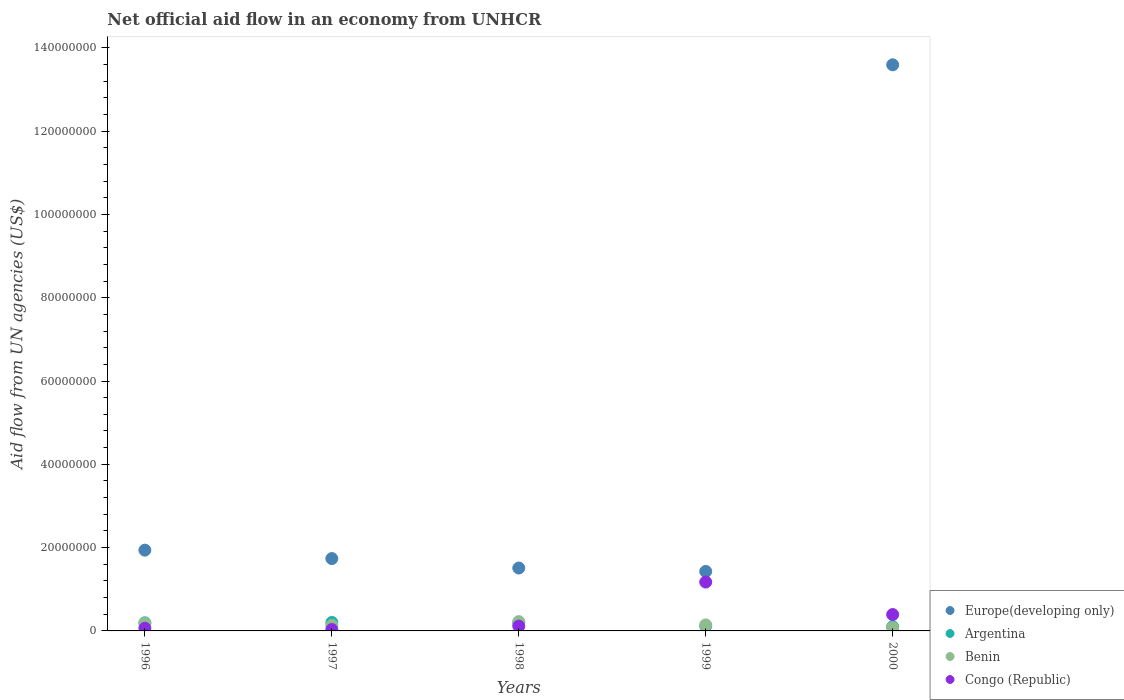Is the number of dotlines equal to the number of legend labels?
Your answer should be compact. Yes. What is the net official aid flow in Argentina in 1999?
Provide a succinct answer. 1.16e+06. Across all years, what is the maximum net official aid flow in Europe(developing only)?
Your answer should be compact. 1.36e+08. Across all years, what is the minimum net official aid flow in Congo (Republic)?
Keep it short and to the point. 3.30e+05. What is the total net official aid flow in Congo (Republic) in the graph?
Provide a succinct answer. 1.78e+07. What is the difference between the net official aid flow in Benin in 1998 and that in 2000?
Make the answer very short. 1.46e+06. What is the difference between the net official aid flow in Benin in 1997 and the net official aid flow in Congo (Republic) in 2000?
Offer a terse response. -2.59e+06. What is the average net official aid flow in Benin per year?
Make the answer very short. 1.52e+06. In the year 1997, what is the difference between the net official aid flow in Congo (Republic) and net official aid flow in Europe(developing only)?
Provide a succinct answer. -1.70e+07. In how many years, is the net official aid flow in Benin greater than 12000000 US$?
Ensure brevity in your answer.  0. What is the ratio of the net official aid flow in Benin in 1998 to that in 2000?
Offer a very short reply. 2.9. Is the net official aid flow in Benin in 1997 less than that in 1999?
Provide a succinct answer. Yes. Is the difference between the net official aid flow in Congo (Republic) in 1997 and 1998 greater than the difference between the net official aid flow in Europe(developing only) in 1997 and 1998?
Your response must be concise. No. What is the difference between the highest and the second highest net official aid flow in Benin?
Give a very brief answer. 4.40e+05. What is the difference between the highest and the lowest net official aid flow in Congo (Republic)?
Offer a very short reply. 1.14e+07. In how many years, is the net official aid flow in Congo (Republic) greater than the average net official aid flow in Congo (Republic) taken over all years?
Give a very brief answer. 2. Is it the case that in every year, the sum of the net official aid flow in Congo (Republic) and net official aid flow in Europe(developing only)  is greater than the sum of net official aid flow in Benin and net official aid flow in Argentina?
Keep it short and to the point. No. Is the net official aid flow in Benin strictly greater than the net official aid flow in Congo (Republic) over the years?
Keep it short and to the point. No. How many years are there in the graph?
Provide a succinct answer. 5. What is the difference between two consecutive major ticks on the Y-axis?
Keep it short and to the point. 2.00e+07. Does the graph contain grids?
Give a very brief answer. No. Where does the legend appear in the graph?
Provide a succinct answer. Bottom right. What is the title of the graph?
Provide a succinct answer. Net official aid flow in an economy from UNHCR. What is the label or title of the Y-axis?
Provide a succinct answer. Aid flow from UN agencies (US$). What is the Aid flow from UN agencies (US$) in Europe(developing only) in 1996?
Your answer should be compact. 1.94e+07. What is the Aid flow from UN agencies (US$) in Argentina in 1996?
Offer a very short reply. 1.95e+06. What is the Aid flow from UN agencies (US$) in Benin in 1996?
Ensure brevity in your answer.  1.79e+06. What is the Aid flow from UN agencies (US$) in Congo (Republic) in 1996?
Keep it short and to the point. 6.50e+05. What is the Aid flow from UN agencies (US$) in Europe(developing only) in 1997?
Make the answer very short. 1.74e+07. What is the Aid flow from UN agencies (US$) of Argentina in 1997?
Offer a terse response. 2.04e+06. What is the Aid flow from UN agencies (US$) of Benin in 1997?
Give a very brief answer. 1.34e+06. What is the Aid flow from UN agencies (US$) of Europe(developing only) in 1998?
Your answer should be very brief. 1.51e+07. What is the Aid flow from UN agencies (US$) in Argentina in 1998?
Your answer should be compact. 1.97e+06. What is the Aid flow from UN agencies (US$) in Benin in 1998?
Ensure brevity in your answer.  2.23e+06. What is the Aid flow from UN agencies (US$) of Congo (Republic) in 1998?
Make the answer very short. 1.15e+06. What is the Aid flow from UN agencies (US$) of Europe(developing only) in 1999?
Offer a terse response. 1.43e+07. What is the Aid flow from UN agencies (US$) in Argentina in 1999?
Give a very brief answer. 1.16e+06. What is the Aid flow from UN agencies (US$) of Benin in 1999?
Your answer should be very brief. 1.45e+06. What is the Aid flow from UN agencies (US$) in Congo (Republic) in 1999?
Give a very brief answer. 1.17e+07. What is the Aid flow from UN agencies (US$) in Europe(developing only) in 2000?
Offer a terse response. 1.36e+08. What is the Aid flow from UN agencies (US$) in Argentina in 2000?
Keep it short and to the point. 1.02e+06. What is the Aid flow from UN agencies (US$) in Benin in 2000?
Provide a short and direct response. 7.70e+05. What is the Aid flow from UN agencies (US$) in Congo (Republic) in 2000?
Provide a short and direct response. 3.93e+06. Across all years, what is the maximum Aid flow from UN agencies (US$) in Europe(developing only)?
Keep it short and to the point. 1.36e+08. Across all years, what is the maximum Aid flow from UN agencies (US$) in Argentina?
Offer a terse response. 2.04e+06. Across all years, what is the maximum Aid flow from UN agencies (US$) of Benin?
Your response must be concise. 2.23e+06. Across all years, what is the maximum Aid flow from UN agencies (US$) of Congo (Republic)?
Your answer should be very brief. 1.17e+07. Across all years, what is the minimum Aid flow from UN agencies (US$) of Europe(developing only)?
Provide a succinct answer. 1.43e+07. Across all years, what is the minimum Aid flow from UN agencies (US$) of Argentina?
Make the answer very short. 1.02e+06. Across all years, what is the minimum Aid flow from UN agencies (US$) of Benin?
Your answer should be compact. 7.70e+05. Across all years, what is the minimum Aid flow from UN agencies (US$) of Congo (Republic)?
Your response must be concise. 3.30e+05. What is the total Aid flow from UN agencies (US$) in Europe(developing only) in the graph?
Provide a short and direct response. 2.02e+08. What is the total Aid flow from UN agencies (US$) of Argentina in the graph?
Your answer should be compact. 8.14e+06. What is the total Aid flow from UN agencies (US$) of Benin in the graph?
Your answer should be very brief. 7.58e+06. What is the total Aid flow from UN agencies (US$) of Congo (Republic) in the graph?
Your answer should be very brief. 1.78e+07. What is the difference between the Aid flow from UN agencies (US$) of Europe(developing only) in 1996 and that in 1997?
Provide a succinct answer. 2.02e+06. What is the difference between the Aid flow from UN agencies (US$) in Europe(developing only) in 1996 and that in 1998?
Offer a terse response. 4.29e+06. What is the difference between the Aid flow from UN agencies (US$) in Argentina in 1996 and that in 1998?
Ensure brevity in your answer.  -2.00e+04. What is the difference between the Aid flow from UN agencies (US$) in Benin in 1996 and that in 1998?
Offer a terse response. -4.40e+05. What is the difference between the Aid flow from UN agencies (US$) of Congo (Republic) in 1996 and that in 1998?
Offer a very short reply. -5.00e+05. What is the difference between the Aid flow from UN agencies (US$) in Europe(developing only) in 1996 and that in 1999?
Provide a short and direct response. 5.11e+06. What is the difference between the Aid flow from UN agencies (US$) in Argentina in 1996 and that in 1999?
Ensure brevity in your answer.  7.90e+05. What is the difference between the Aid flow from UN agencies (US$) of Benin in 1996 and that in 1999?
Offer a terse response. 3.40e+05. What is the difference between the Aid flow from UN agencies (US$) in Congo (Republic) in 1996 and that in 1999?
Give a very brief answer. -1.11e+07. What is the difference between the Aid flow from UN agencies (US$) in Europe(developing only) in 1996 and that in 2000?
Offer a very short reply. -1.17e+08. What is the difference between the Aid flow from UN agencies (US$) in Argentina in 1996 and that in 2000?
Offer a very short reply. 9.30e+05. What is the difference between the Aid flow from UN agencies (US$) of Benin in 1996 and that in 2000?
Give a very brief answer. 1.02e+06. What is the difference between the Aid flow from UN agencies (US$) in Congo (Republic) in 1996 and that in 2000?
Provide a succinct answer. -3.28e+06. What is the difference between the Aid flow from UN agencies (US$) of Europe(developing only) in 1997 and that in 1998?
Offer a very short reply. 2.27e+06. What is the difference between the Aid flow from UN agencies (US$) in Benin in 1997 and that in 1998?
Offer a terse response. -8.90e+05. What is the difference between the Aid flow from UN agencies (US$) in Congo (Republic) in 1997 and that in 1998?
Give a very brief answer. -8.20e+05. What is the difference between the Aid flow from UN agencies (US$) in Europe(developing only) in 1997 and that in 1999?
Make the answer very short. 3.09e+06. What is the difference between the Aid flow from UN agencies (US$) in Argentina in 1997 and that in 1999?
Your answer should be very brief. 8.80e+05. What is the difference between the Aid flow from UN agencies (US$) in Benin in 1997 and that in 1999?
Your response must be concise. -1.10e+05. What is the difference between the Aid flow from UN agencies (US$) of Congo (Republic) in 1997 and that in 1999?
Your answer should be compact. -1.14e+07. What is the difference between the Aid flow from UN agencies (US$) of Europe(developing only) in 1997 and that in 2000?
Your answer should be compact. -1.19e+08. What is the difference between the Aid flow from UN agencies (US$) of Argentina in 1997 and that in 2000?
Give a very brief answer. 1.02e+06. What is the difference between the Aid flow from UN agencies (US$) in Benin in 1997 and that in 2000?
Give a very brief answer. 5.70e+05. What is the difference between the Aid flow from UN agencies (US$) of Congo (Republic) in 1997 and that in 2000?
Offer a terse response. -3.60e+06. What is the difference between the Aid flow from UN agencies (US$) of Europe(developing only) in 1998 and that in 1999?
Offer a terse response. 8.20e+05. What is the difference between the Aid flow from UN agencies (US$) in Argentina in 1998 and that in 1999?
Offer a very short reply. 8.10e+05. What is the difference between the Aid flow from UN agencies (US$) of Benin in 1998 and that in 1999?
Ensure brevity in your answer.  7.80e+05. What is the difference between the Aid flow from UN agencies (US$) in Congo (Republic) in 1998 and that in 1999?
Your answer should be compact. -1.06e+07. What is the difference between the Aid flow from UN agencies (US$) in Europe(developing only) in 1998 and that in 2000?
Provide a short and direct response. -1.21e+08. What is the difference between the Aid flow from UN agencies (US$) of Argentina in 1998 and that in 2000?
Your response must be concise. 9.50e+05. What is the difference between the Aid flow from UN agencies (US$) in Benin in 1998 and that in 2000?
Your response must be concise. 1.46e+06. What is the difference between the Aid flow from UN agencies (US$) in Congo (Republic) in 1998 and that in 2000?
Offer a very short reply. -2.78e+06. What is the difference between the Aid flow from UN agencies (US$) of Europe(developing only) in 1999 and that in 2000?
Your answer should be compact. -1.22e+08. What is the difference between the Aid flow from UN agencies (US$) in Benin in 1999 and that in 2000?
Give a very brief answer. 6.80e+05. What is the difference between the Aid flow from UN agencies (US$) in Congo (Republic) in 1999 and that in 2000?
Offer a terse response. 7.80e+06. What is the difference between the Aid flow from UN agencies (US$) of Europe(developing only) in 1996 and the Aid flow from UN agencies (US$) of Argentina in 1997?
Ensure brevity in your answer.  1.74e+07. What is the difference between the Aid flow from UN agencies (US$) of Europe(developing only) in 1996 and the Aid flow from UN agencies (US$) of Benin in 1997?
Offer a terse response. 1.80e+07. What is the difference between the Aid flow from UN agencies (US$) in Europe(developing only) in 1996 and the Aid flow from UN agencies (US$) in Congo (Republic) in 1997?
Ensure brevity in your answer.  1.91e+07. What is the difference between the Aid flow from UN agencies (US$) in Argentina in 1996 and the Aid flow from UN agencies (US$) in Congo (Republic) in 1997?
Make the answer very short. 1.62e+06. What is the difference between the Aid flow from UN agencies (US$) in Benin in 1996 and the Aid flow from UN agencies (US$) in Congo (Republic) in 1997?
Your answer should be very brief. 1.46e+06. What is the difference between the Aid flow from UN agencies (US$) in Europe(developing only) in 1996 and the Aid flow from UN agencies (US$) in Argentina in 1998?
Ensure brevity in your answer.  1.74e+07. What is the difference between the Aid flow from UN agencies (US$) in Europe(developing only) in 1996 and the Aid flow from UN agencies (US$) in Benin in 1998?
Provide a short and direct response. 1.72e+07. What is the difference between the Aid flow from UN agencies (US$) of Europe(developing only) in 1996 and the Aid flow from UN agencies (US$) of Congo (Republic) in 1998?
Make the answer very short. 1.82e+07. What is the difference between the Aid flow from UN agencies (US$) of Argentina in 1996 and the Aid flow from UN agencies (US$) of Benin in 1998?
Your answer should be very brief. -2.80e+05. What is the difference between the Aid flow from UN agencies (US$) in Argentina in 1996 and the Aid flow from UN agencies (US$) in Congo (Republic) in 1998?
Give a very brief answer. 8.00e+05. What is the difference between the Aid flow from UN agencies (US$) of Benin in 1996 and the Aid flow from UN agencies (US$) of Congo (Republic) in 1998?
Your response must be concise. 6.40e+05. What is the difference between the Aid flow from UN agencies (US$) of Europe(developing only) in 1996 and the Aid flow from UN agencies (US$) of Argentina in 1999?
Offer a very short reply. 1.82e+07. What is the difference between the Aid flow from UN agencies (US$) in Europe(developing only) in 1996 and the Aid flow from UN agencies (US$) in Benin in 1999?
Your answer should be compact. 1.79e+07. What is the difference between the Aid flow from UN agencies (US$) in Europe(developing only) in 1996 and the Aid flow from UN agencies (US$) in Congo (Republic) in 1999?
Offer a very short reply. 7.66e+06. What is the difference between the Aid flow from UN agencies (US$) of Argentina in 1996 and the Aid flow from UN agencies (US$) of Congo (Republic) in 1999?
Your answer should be compact. -9.78e+06. What is the difference between the Aid flow from UN agencies (US$) in Benin in 1996 and the Aid flow from UN agencies (US$) in Congo (Republic) in 1999?
Your answer should be compact. -9.94e+06. What is the difference between the Aid flow from UN agencies (US$) in Europe(developing only) in 1996 and the Aid flow from UN agencies (US$) in Argentina in 2000?
Your response must be concise. 1.84e+07. What is the difference between the Aid flow from UN agencies (US$) of Europe(developing only) in 1996 and the Aid flow from UN agencies (US$) of Benin in 2000?
Keep it short and to the point. 1.86e+07. What is the difference between the Aid flow from UN agencies (US$) in Europe(developing only) in 1996 and the Aid flow from UN agencies (US$) in Congo (Republic) in 2000?
Your answer should be very brief. 1.55e+07. What is the difference between the Aid flow from UN agencies (US$) of Argentina in 1996 and the Aid flow from UN agencies (US$) of Benin in 2000?
Your response must be concise. 1.18e+06. What is the difference between the Aid flow from UN agencies (US$) of Argentina in 1996 and the Aid flow from UN agencies (US$) of Congo (Republic) in 2000?
Ensure brevity in your answer.  -1.98e+06. What is the difference between the Aid flow from UN agencies (US$) of Benin in 1996 and the Aid flow from UN agencies (US$) of Congo (Republic) in 2000?
Keep it short and to the point. -2.14e+06. What is the difference between the Aid flow from UN agencies (US$) of Europe(developing only) in 1997 and the Aid flow from UN agencies (US$) of Argentina in 1998?
Your response must be concise. 1.54e+07. What is the difference between the Aid flow from UN agencies (US$) in Europe(developing only) in 1997 and the Aid flow from UN agencies (US$) in Benin in 1998?
Your answer should be very brief. 1.51e+07. What is the difference between the Aid flow from UN agencies (US$) in Europe(developing only) in 1997 and the Aid flow from UN agencies (US$) in Congo (Republic) in 1998?
Provide a short and direct response. 1.62e+07. What is the difference between the Aid flow from UN agencies (US$) of Argentina in 1997 and the Aid flow from UN agencies (US$) of Congo (Republic) in 1998?
Offer a terse response. 8.90e+05. What is the difference between the Aid flow from UN agencies (US$) in Europe(developing only) in 1997 and the Aid flow from UN agencies (US$) in Argentina in 1999?
Your answer should be compact. 1.62e+07. What is the difference between the Aid flow from UN agencies (US$) of Europe(developing only) in 1997 and the Aid flow from UN agencies (US$) of Benin in 1999?
Make the answer very short. 1.59e+07. What is the difference between the Aid flow from UN agencies (US$) of Europe(developing only) in 1997 and the Aid flow from UN agencies (US$) of Congo (Republic) in 1999?
Make the answer very short. 5.64e+06. What is the difference between the Aid flow from UN agencies (US$) of Argentina in 1997 and the Aid flow from UN agencies (US$) of Benin in 1999?
Your answer should be compact. 5.90e+05. What is the difference between the Aid flow from UN agencies (US$) of Argentina in 1997 and the Aid flow from UN agencies (US$) of Congo (Republic) in 1999?
Offer a very short reply. -9.69e+06. What is the difference between the Aid flow from UN agencies (US$) in Benin in 1997 and the Aid flow from UN agencies (US$) in Congo (Republic) in 1999?
Offer a very short reply. -1.04e+07. What is the difference between the Aid flow from UN agencies (US$) of Europe(developing only) in 1997 and the Aid flow from UN agencies (US$) of Argentina in 2000?
Keep it short and to the point. 1.64e+07. What is the difference between the Aid flow from UN agencies (US$) of Europe(developing only) in 1997 and the Aid flow from UN agencies (US$) of Benin in 2000?
Your answer should be very brief. 1.66e+07. What is the difference between the Aid flow from UN agencies (US$) of Europe(developing only) in 1997 and the Aid flow from UN agencies (US$) of Congo (Republic) in 2000?
Provide a succinct answer. 1.34e+07. What is the difference between the Aid flow from UN agencies (US$) of Argentina in 1997 and the Aid flow from UN agencies (US$) of Benin in 2000?
Give a very brief answer. 1.27e+06. What is the difference between the Aid flow from UN agencies (US$) in Argentina in 1997 and the Aid flow from UN agencies (US$) in Congo (Republic) in 2000?
Offer a terse response. -1.89e+06. What is the difference between the Aid flow from UN agencies (US$) in Benin in 1997 and the Aid flow from UN agencies (US$) in Congo (Republic) in 2000?
Provide a short and direct response. -2.59e+06. What is the difference between the Aid flow from UN agencies (US$) in Europe(developing only) in 1998 and the Aid flow from UN agencies (US$) in Argentina in 1999?
Your answer should be compact. 1.39e+07. What is the difference between the Aid flow from UN agencies (US$) in Europe(developing only) in 1998 and the Aid flow from UN agencies (US$) in Benin in 1999?
Offer a very short reply. 1.36e+07. What is the difference between the Aid flow from UN agencies (US$) of Europe(developing only) in 1998 and the Aid flow from UN agencies (US$) of Congo (Republic) in 1999?
Your answer should be very brief. 3.37e+06. What is the difference between the Aid flow from UN agencies (US$) in Argentina in 1998 and the Aid flow from UN agencies (US$) in Benin in 1999?
Offer a terse response. 5.20e+05. What is the difference between the Aid flow from UN agencies (US$) in Argentina in 1998 and the Aid flow from UN agencies (US$) in Congo (Republic) in 1999?
Your answer should be compact. -9.76e+06. What is the difference between the Aid flow from UN agencies (US$) in Benin in 1998 and the Aid flow from UN agencies (US$) in Congo (Republic) in 1999?
Give a very brief answer. -9.50e+06. What is the difference between the Aid flow from UN agencies (US$) of Europe(developing only) in 1998 and the Aid flow from UN agencies (US$) of Argentina in 2000?
Make the answer very short. 1.41e+07. What is the difference between the Aid flow from UN agencies (US$) of Europe(developing only) in 1998 and the Aid flow from UN agencies (US$) of Benin in 2000?
Ensure brevity in your answer.  1.43e+07. What is the difference between the Aid flow from UN agencies (US$) in Europe(developing only) in 1998 and the Aid flow from UN agencies (US$) in Congo (Republic) in 2000?
Give a very brief answer. 1.12e+07. What is the difference between the Aid flow from UN agencies (US$) of Argentina in 1998 and the Aid flow from UN agencies (US$) of Benin in 2000?
Offer a very short reply. 1.20e+06. What is the difference between the Aid flow from UN agencies (US$) in Argentina in 1998 and the Aid flow from UN agencies (US$) in Congo (Republic) in 2000?
Your answer should be very brief. -1.96e+06. What is the difference between the Aid flow from UN agencies (US$) of Benin in 1998 and the Aid flow from UN agencies (US$) of Congo (Republic) in 2000?
Offer a terse response. -1.70e+06. What is the difference between the Aid flow from UN agencies (US$) of Europe(developing only) in 1999 and the Aid flow from UN agencies (US$) of Argentina in 2000?
Make the answer very short. 1.33e+07. What is the difference between the Aid flow from UN agencies (US$) in Europe(developing only) in 1999 and the Aid flow from UN agencies (US$) in Benin in 2000?
Keep it short and to the point. 1.35e+07. What is the difference between the Aid flow from UN agencies (US$) of Europe(developing only) in 1999 and the Aid flow from UN agencies (US$) of Congo (Republic) in 2000?
Keep it short and to the point. 1.04e+07. What is the difference between the Aid flow from UN agencies (US$) in Argentina in 1999 and the Aid flow from UN agencies (US$) in Benin in 2000?
Make the answer very short. 3.90e+05. What is the difference between the Aid flow from UN agencies (US$) in Argentina in 1999 and the Aid flow from UN agencies (US$) in Congo (Republic) in 2000?
Offer a terse response. -2.77e+06. What is the difference between the Aid flow from UN agencies (US$) in Benin in 1999 and the Aid flow from UN agencies (US$) in Congo (Republic) in 2000?
Provide a short and direct response. -2.48e+06. What is the average Aid flow from UN agencies (US$) of Europe(developing only) per year?
Provide a succinct answer. 4.04e+07. What is the average Aid flow from UN agencies (US$) in Argentina per year?
Give a very brief answer. 1.63e+06. What is the average Aid flow from UN agencies (US$) in Benin per year?
Keep it short and to the point. 1.52e+06. What is the average Aid flow from UN agencies (US$) in Congo (Republic) per year?
Ensure brevity in your answer.  3.56e+06. In the year 1996, what is the difference between the Aid flow from UN agencies (US$) of Europe(developing only) and Aid flow from UN agencies (US$) of Argentina?
Provide a succinct answer. 1.74e+07. In the year 1996, what is the difference between the Aid flow from UN agencies (US$) in Europe(developing only) and Aid flow from UN agencies (US$) in Benin?
Your answer should be compact. 1.76e+07. In the year 1996, what is the difference between the Aid flow from UN agencies (US$) in Europe(developing only) and Aid flow from UN agencies (US$) in Congo (Republic)?
Provide a short and direct response. 1.87e+07. In the year 1996, what is the difference between the Aid flow from UN agencies (US$) of Argentina and Aid flow from UN agencies (US$) of Benin?
Offer a very short reply. 1.60e+05. In the year 1996, what is the difference between the Aid flow from UN agencies (US$) of Argentina and Aid flow from UN agencies (US$) of Congo (Republic)?
Your answer should be compact. 1.30e+06. In the year 1996, what is the difference between the Aid flow from UN agencies (US$) of Benin and Aid flow from UN agencies (US$) of Congo (Republic)?
Provide a succinct answer. 1.14e+06. In the year 1997, what is the difference between the Aid flow from UN agencies (US$) of Europe(developing only) and Aid flow from UN agencies (US$) of Argentina?
Provide a short and direct response. 1.53e+07. In the year 1997, what is the difference between the Aid flow from UN agencies (US$) of Europe(developing only) and Aid flow from UN agencies (US$) of Benin?
Your answer should be compact. 1.60e+07. In the year 1997, what is the difference between the Aid flow from UN agencies (US$) in Europe(developing only) and Aid flow from UN agencies (US$) in Congo (Republic)?
Provide a succinct answer. 1.70e+07. In the year 1997, what is the difference between the Aid flow from UN agencies (US$) of Argentina and Aid flow from UN agencies (US$) of Benin?
Provide a short and direct response. 7.00e+05. In the year 1997, what is the difference between the Aid flow from UN agencies (US$) in Argentina and Aid flow from UN agencies (US$) in Congo (Republic)?
Make the answer very short. 1.71e+06. In the year 1997, what is the difference between the Aid flow from UN agencies (US$) of Benin and Aid flow from UN agencies (US$) of Congo (Republic)?
Your answer should be compact. 1.01e+06. In the year 1998, what is the difference between the Aid flow from UN agencies (US$) in Europe(developing only) and Aid flow from UN agencies (US$) in Argentina?
Provide a short and direct response. 1.31e+07. In the year 1998, what is the difference between the Aid flow from UN agencies (US$) in Europe(developing only) and Aid flow from UN agencies (US$) in Benin?
Provide a short and direct response. 1.29e+07. In the year 1998, what is the difference between the Aid flow from UN agencies (US$) in Europe(developing only) and Aid flow from UN agencies (US$) in Congo (Republic)?
Your answer should be very brief. 1.40e+07. In the year 1998, what is the difference between the Aid flow from UN agencies (US$) of Argentina and Aid flow from UN agencies (US$) of Congo (Republic)?
Offer a very short reply. 8.20e+05. In the year 1998, what is the difference between the Aid flow from UN agencies (US$) in Benin and Aid flow from UN agencies (US$) in Congo (Republic)?
Keep it short and to the point. 1.08e+06. In the year 1999, what is the difference between the Aid flow from UN agencies (US$) in Europe(developing only) and Aid flow from UN agencies (US$) in Argentina?
Provide a succinct answer. 1.31e+07. In the year 1999, what is the difference between the Aid flow from UN agencies (US$) in Europe(developing only) and Aid flow from UN agencies (US$) in Benin?
Offer a terse response. 1.28e+07. In the year 1999, what is the difference between the Aid flow from UN agencies (US$) of Europe(developing only) and Aid flow from UN agencies (US$) of Congo (Republic)?
Ensure brevity in your answer.  2.55e+06. In the year 1999, what is the difference between the Aid flow from UN agencies (US$) in Argentina and Aid flow from UN agencies (US$) in Benin?
Give a very brief answer. -2.90e+05. In the year 1999, what is the difference between the Aid flow from UN agencies (US$) in Argentina and Aid flow from UN agencies (US$) in Congo (Republic)?
Give a very brief answer. -1.06e+07. In the year 1999, what is the difference between the Aid flow from UN agencies (US$) in Benin and Aid flow from UN agencies (US$) in Congo (Republic)?
Give a very brief answer. -1.03e+07. In the year 2000, what is the difference between the Aid flow from UN agencies (US$) of Europe(developing only) and Aid flow from UN agencies (US$) of Argentina?
Provide a succinct answer. 1.35e+08. In the year 2000, what is the difference between the Aid flow from UN agencies (US$) in Europe(developing only) and Aid flow from UN agencies (US$) in Benin?
Ensure brevity in your answer.  1.35e+08. In the year 2000, what is the difference between the Aid flow from UN agencies (US$) of Europe(developing only) and Aid flow from UN agencies (US$) of Congo (Republic)?
Offer a terse response. 1.32e+08. In the year 2000, what is the difference between the Aid flow from UN agencies (US$) of Argentina and Aid flow from UN agencies (US$) of Congo (Republic)?
Offer a terse response. -2.91e+06. In the year 2000, what is the difference between the Aid flow from UN agencies (US$) in Benin and Aid flow from UN agencies (US$) in Congo (Republic)?
Make the answer very short. -3.16e+06. What is the ratio of the Aid flow from UN agencies (US$) in Europe(developing only) in 1996 to that in 1997?
Provide a succinct answer. 1.12. What is the ratio of the Aid flow from UN agencies (US$) in Argentina in 1996 to that in 1997?
Give a very brief answer. 0.96. What is the ratio of the Aid flow from UN agencies (US$) in Benin in 1996 to that in 1997?
Offer a very short reply. 1.34. What is the ratio of the Aid flow from UN agencies (US$) of Congo (Republic) in 1996 to that in 1997?
Your answer should be very brief. 1.97. What is the ratio of the Aid flow from UN agencies (US$) of Europe(developing only) in 1996 to that in 1998?
Your answer should be very brief. 1.28. What is the ratio of the Aid flow from UN agencies (US$) in Argentina in 1996 to that in 1998?
Give a very brief answer. 0.99. What is the ratio of the Aid flow from UN agencies (US$) of Benin in 1996 to that in 1998?
Your answer should be compact. 0.8. What is the ratio of the Aid flow from UN agencies (US$) in Congo (Republic) in 1996 to that in 1998?
Give a very brief answer. 0.57. What is the ratio of the Aid flow from UN agencies (US$) of Europe(developing only) in 1996 to that in 1999?
Offer a very short reply. 1.36. What is the ratio of the Aid flow from UN agencies (US$) of Argentina in 1996 to that in 1999?
Offer a very short reply. 1.68. What is the ratio of the Aid flow from UN agencies (US$) of Benin in 1996 to that in 1999?
Ensure brevity in your answer.  1.23. What is the ratio of the Aid flow from UN agencies (US$) of Congo (Republic) in 1996 to that in 1999?
Offer a very short reply. 0.06. What is the ratio of the Aid flow from UN agencies (US$) in Europe(developing only) in 1996 to that in 2000?
Provide a short and direct response. 0.14. What is the ratio of the Aid flow from UN agencies (US$) in Argentina in 1996 to that in 2000?
Give a very brief answer. 1.91. What is the ratio of the Aid flow from UN agencies (US$) in Benin in 1996 to that in 2000?
Your answer should be very brief. 2.32. What is the ratio of the Aid flow from UN agencies (US$) in Congo (Republic) in 1996 to that in 2000?
Keep it short and to the point. 0.17. What is the ratio of the Aid flow from UN agencies (US$) in Europe(developing only) in 1997 to that in 1998?
Ensure brevity in your answer.  1.15. What is the ratio of the Aid flow from UN agencies (US$) in Argentina in 1997 to that in 1998?
Your answer should be compact. 1.04. What is the ratio of the Aid flow from UN agencies (US$) of Benin in 1997 to that in 1998?
Your answer should be compact. 0.6. What is the ratio of the Aid flow from UN agencies (US$) in Congo (Republic) in 1997 to that in 1998?
Offer a very short reply. 0.29. What is the ratio of the Aid flow from UN agencies (US$) of Europe(developing only) in 1997 to that in 1999?
Offer a very short reply. 1.22. What is the ratio of the Aid flow from UN agencies (US$) of Argentina in 1997 to that in 1999?
Offer a terse response. 1.76. What is the ratio of the Aid flow from UN agencies (US$) of Benin in 1997 to that in 1999?
Offer a very short reply. 0.92. What is the ratio of the Aid flow from UN agencies (US$) of Congo (Republic) in 1997 to that in 1999?
Provide a short and direct response. 0.03. What is the ratio of the Aid flow from UN agencies (US$) of Europe(developing only) in 1997 to that in 2000?
Give a very brief answer. 0.13. What is the ratio of the Aid flow from UN agencies (US$) in Argentina in 1997 to that in 2000?
Keep it short and to the point. 2. What is the ratio of the Aid flow from UN agencies (US$) in Benin in 1997 to that in 2000?
Make the answer very short. 1.74. What is the ratio of the Aid flow from UN agencies (US$) in Congo (Republic) in 1997 to that in 2000?
Ensure brevity in your answer.  0.08. What is the ratio of the Aid flow from UN agencies (US$) of Europe(developing only) in 1998 to that in 1999?
Your answer should be very brief. 1.06. What is the ratio of the Aid flow from UN agencies (US$) of Argentina in 1998 to that in 1999?
Give a very brief answer. 1.7. What is the ratio of the Aid flow from UN agencies (US$) in Benin in 1998 to that in 1999?
Provide a succinct answer. 1.54. What is the ratio of the Aid flow from UN agencies (US$) in Congo (Republic) in 1998 to that in 1999?
Make the answer very short. 0.1. What is the ratio of the Aid flow from UN agencies (US$) in Europe(developing only) in 1998 to that in 2000?
Provide a short and direct response. 0.11. What is the ratio of the Aid flow from UN agencies (US$) of Argentina in 1998 to that in 2000?
Make the answer very short. 1.93. What is the ratio of the Aid flow from UN agencies (US$) of Benin in 1998 to that in 2000?
Provide a short and direct response. 2.9. What is the ratio of the Aid flow from UN agencies (US$) in Congo (Republic) in 1998 to that in 2000?
Provide a succinct answer. 0.29. What is the ratio of the Aid flow from UN agencies (US$) of Europe(developing only) in 1999 to that in 2000?
Your answer should be very brief. 0.11. What is the ratio of the Aid flow from UN agencies (US$) in Argentina in 1999 to that in 2000?
Offer a very short reply. 1.14. What is the ratio of the Aid flow from UN agencies (US$) of Benin in 1999 to that in 2000?
Offer a terse response. 1.88. What is the ratio of the Aid flow from UN agencies (US$) of Congo (Republic) in 1999 to that in 2000?
Keep it short and to the point. 2.98. What is the difference between the highest and the second highest Aid flow from UN agencies (US$) of Europe(developing only)?
Keep it short and to the point. 1.17e+08. What is the difference between the highest and the second highest Aid flow from UN agencies (US$) in Congo (Republic)?
Your answer should be compact. 7.80e+06. What is the difference between the highest and the lowest Aid flow from UN agencies (US$) of Europe(developing only)?
Your answer should be compact. 1.22e+08. What is the difference between the highest and the lowest Aid flow from UN agencies (US$) of Argentina?
Offer a very short reply. 1.02e+06. What is the difference between the highest and the lowest Aid flow from UN agencies (US$) of Benin?
Your answer should be compact. 1.46e+06. What is the difference between the highest and the lowest Aid flow from UN agencies (US$) of Congo (Republic)?
Provide a succinct answer. 1.14e+07. 